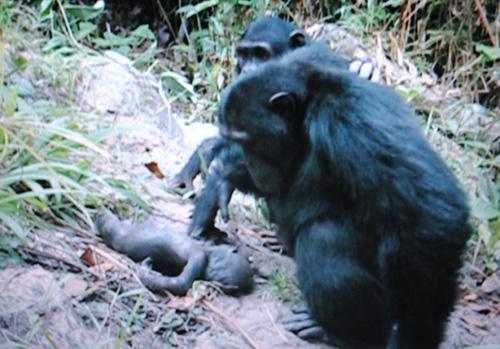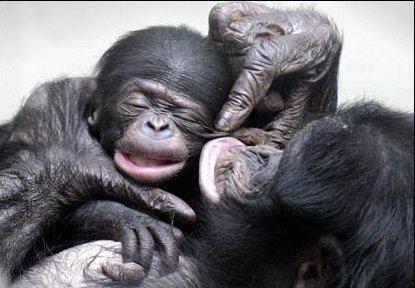The first image is the image on the left, the second image is the image on the right. Given the left and right images, does the statement "There is a total of four chimpanzees in the image pair." hold true? Answer yes or no. No. The first image is the image on the left, the second image is the image on the right. Examine the images to the left and right. Is the description "One animal in the image on the right side is standing upright." accurate? Answer yes or no. No. The first image is the image on the left, the second image is the image on the right. Evaluate the accuracy of this statement regarding the images: "An image shows at least one adult chimp looking at a tiny body lying on the ground.". Is it true? Answer yes or no. Yes. The first image is the image on the left, the second image is the image on the right. Evaluate the accuracy of this statement regarding the images: "An image shows at least one chimp bent downward to look at a tiny body lying on the ground.". Is it true? Answer yes or no. Yes. 